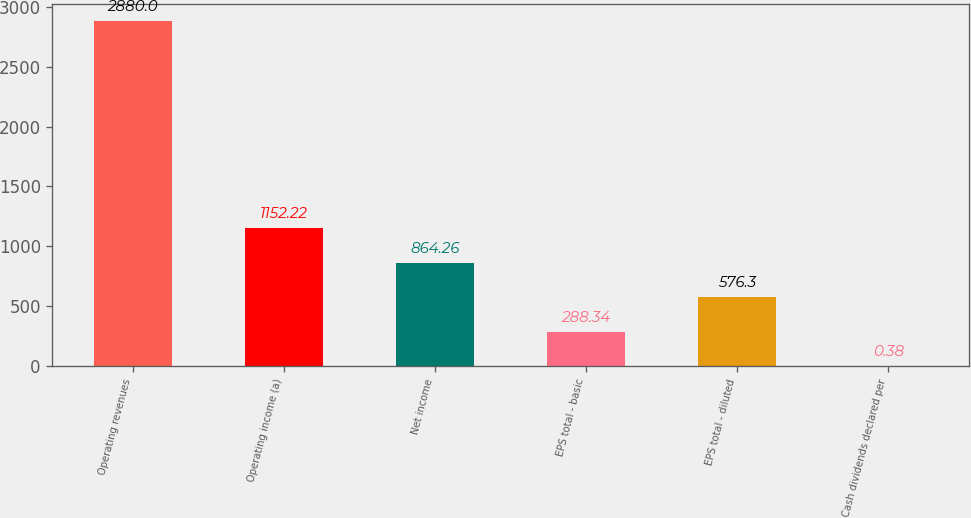Convert chart. <chart><loc_0><loc_0><loc_500><loc_500><bar_chart><fcel>Operating revenues<fcel>Operating income (a)<fcel>Net income<fcel>EPS total - basic<fcel>EPS total - diluted<fcel>Cash dividends declared per<nl><fcel>2880<fcel>1152.22<fcel>864.26<fcel>288.34<fcel>576.3<fcel>0.38<nl></chart> 